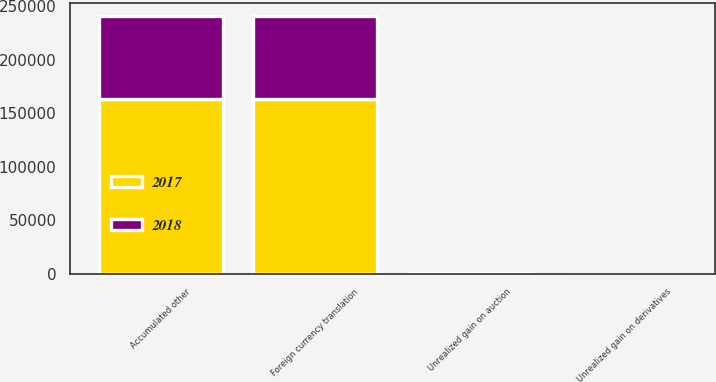<chart> <loc_0><loc_0><loc_500><loc_500><stacked_bar_chart><ecel><fcel>Foreign currency translation<fcel>Unrealized gain on auction<fcel>Unrealized gain on derivatives<fcel>Accumulated other<nl><fcel>2017<fcel>163155<fcel>232<fcel>27<fcel>162896<nl><fcel>2018<fcel>77578<fcel>232<fcel>2<fcel>77344<nl></chart> 